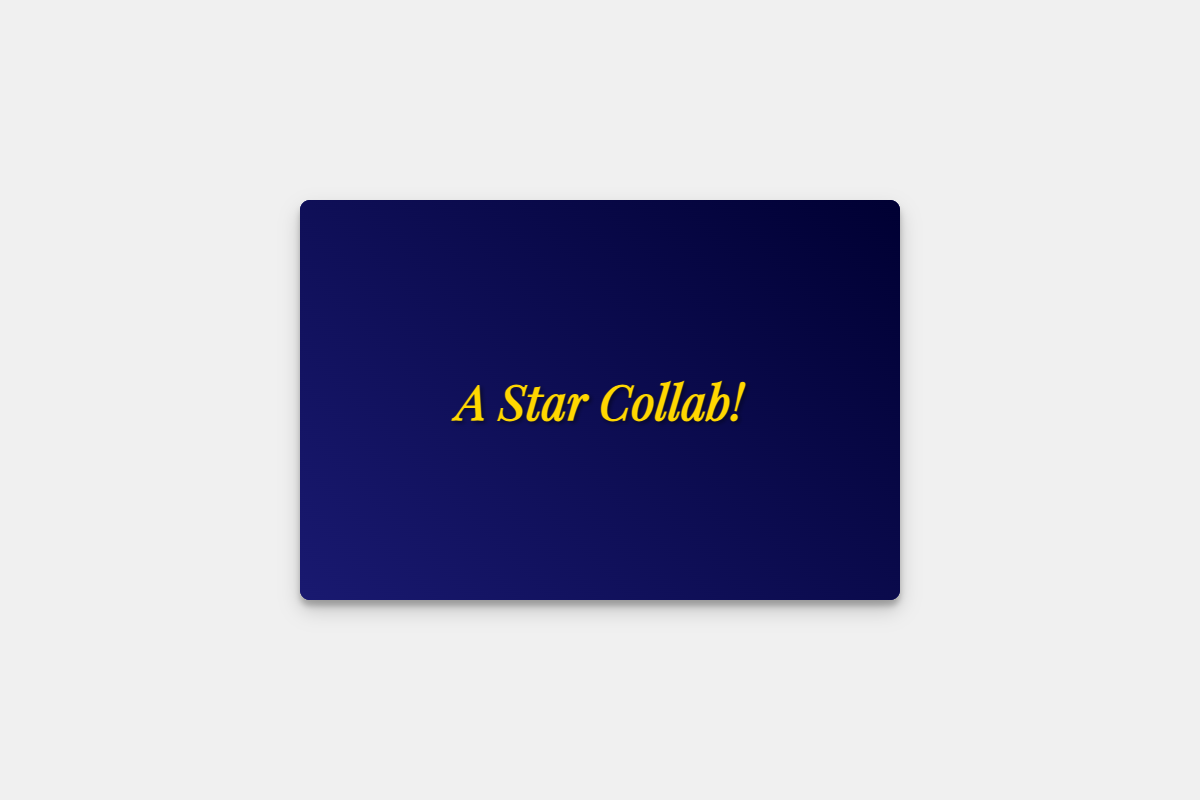What is the title of the greeting card? The title of the greeting card is indicated prominently at the top of the card.
Answer: A Star Collab! Who is the greeting card addressed to? The card includes a placeholder for the recipient's name, indicating who the message is directed towards.
Answer: [Partner's Name] What project is mentioned in the card? The card has a placeholder for the project name, which is part of the heartfelt message.
Answer: [Project Name] What color is the background of the card? The card features a gradient background that transitions between two colors, which is a key visual element.
Answer: Dark Blue What type of props are displayed in the pop-up design? The design includes imagery of specific items related to film production that enhance the theme of the card.
Answer: Camera and director's chair What is the tone of the message in the card? The tone is reflective and grateful, emphasizing the positive experience of collaboration.
Answer: Heartfelt What metaphor is used in the closing note? The closing note uses a theatrical metaphor to reflect on shared experiences and future opportunities.
Answer: Curtain falling How many main visual elements are included in the pop-up design? The pop-up design incorporates multiple props that provide depth and a film-themed setting.
Answer: Two What is the text color on the front cover of the card? The text color is prominent and designed to stand out against the background, enhancing readability.
Answer: Gold 